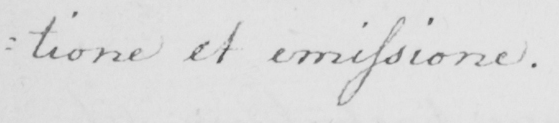What does this handwritten line say? : tione et emissione . 